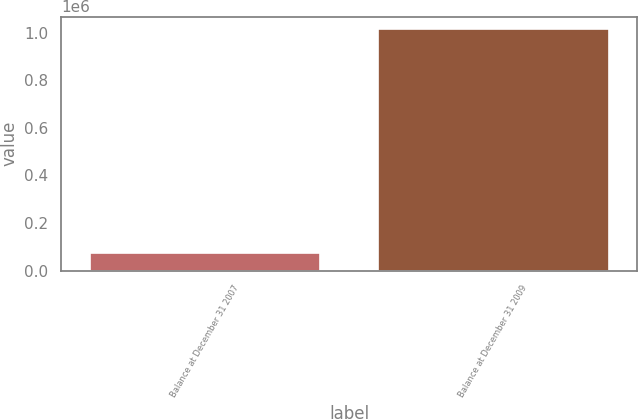Convert chart. <chart><loc_0><loc_0><loc_500><loc_500><bar_chart><fcel>Balance at December 31 2007<fcel>Balance at December 31 2009<nl><fcel>74400<fcel>1.01662e+06<nl></chart> 